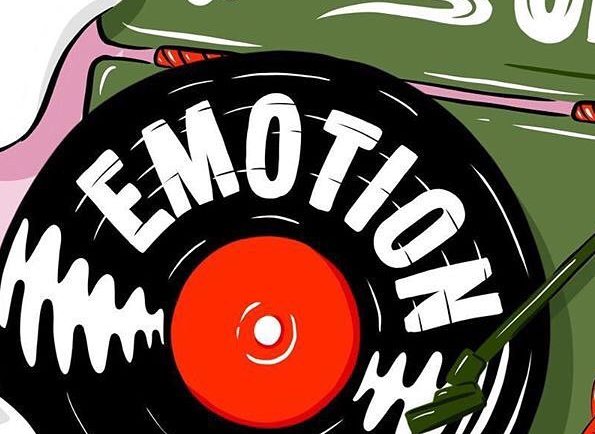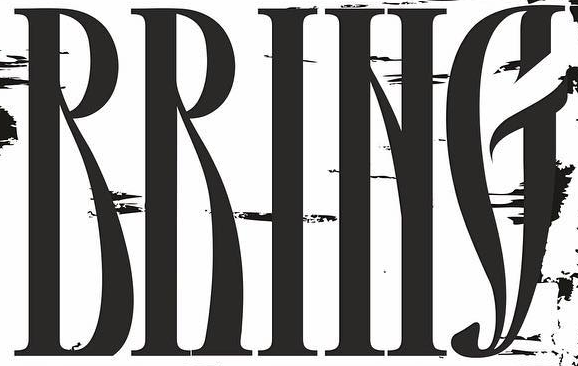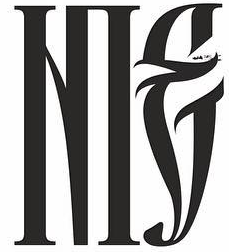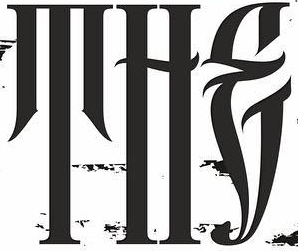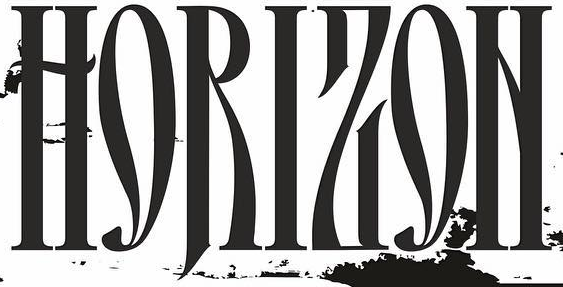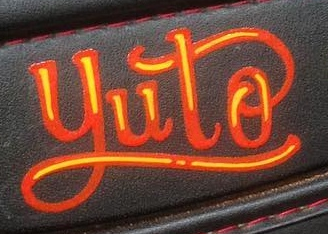What words can you see in these images in sequence, separated by a semicolon? EMOTION; RRING; NIE; THE; HORIZON; yuto 